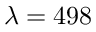<formula> <loc_0><loc_0><loc_500><loc_500>\lambda = 4 9 8</formula> 